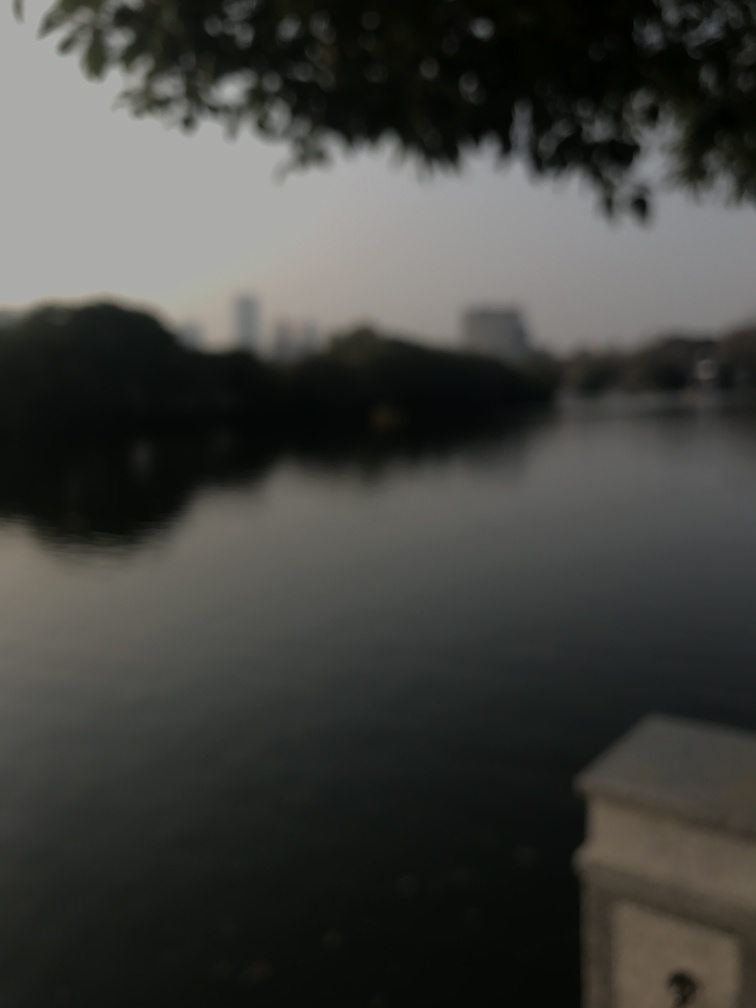Can you describe the mood or atmosphere of this image? The image evokes a tranquil and serene mood. The muted colors and blurred details contribute to a sense of calm and stillness. This could be a place where one goes to reflect or escape the busyness of daily life. The atmosphere is contemplative, inviting the viewer to fill in the details with their imagination. 